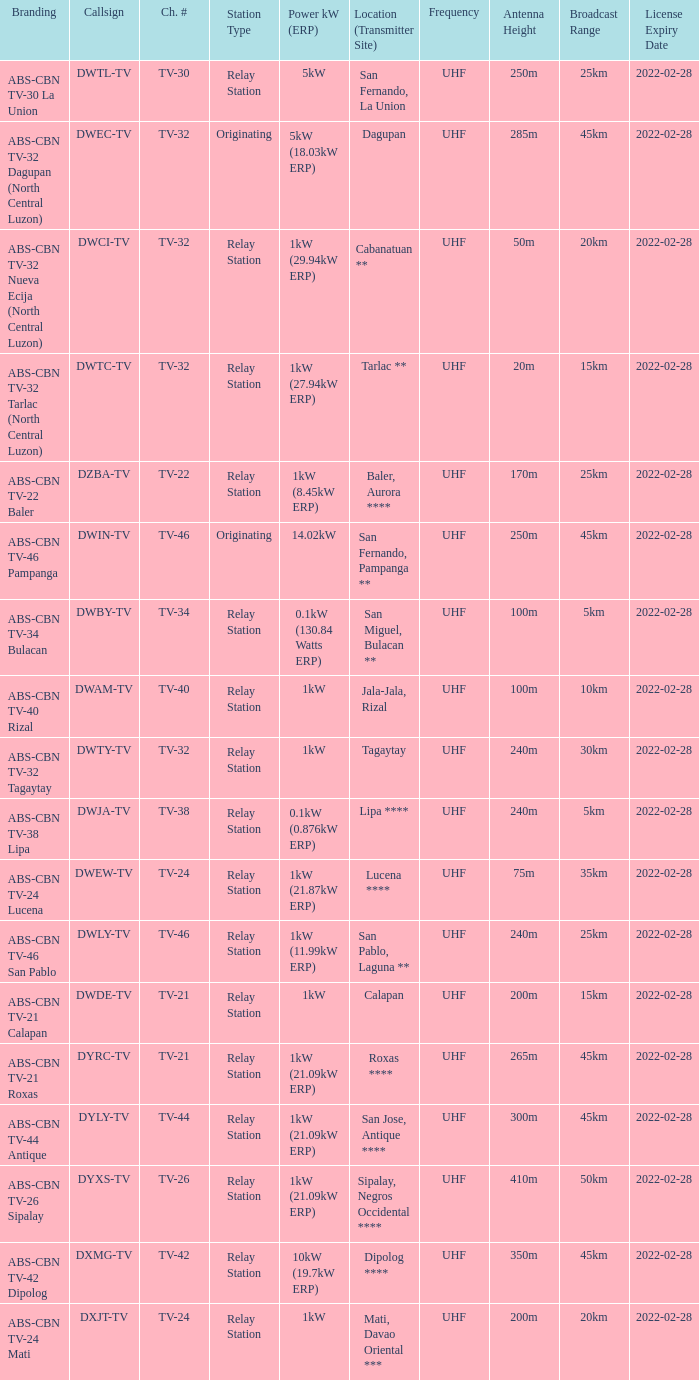The callsign DWEC-TV has what branding?  ABS-CBN TV-32 Dagupan (North Central Luzon). 